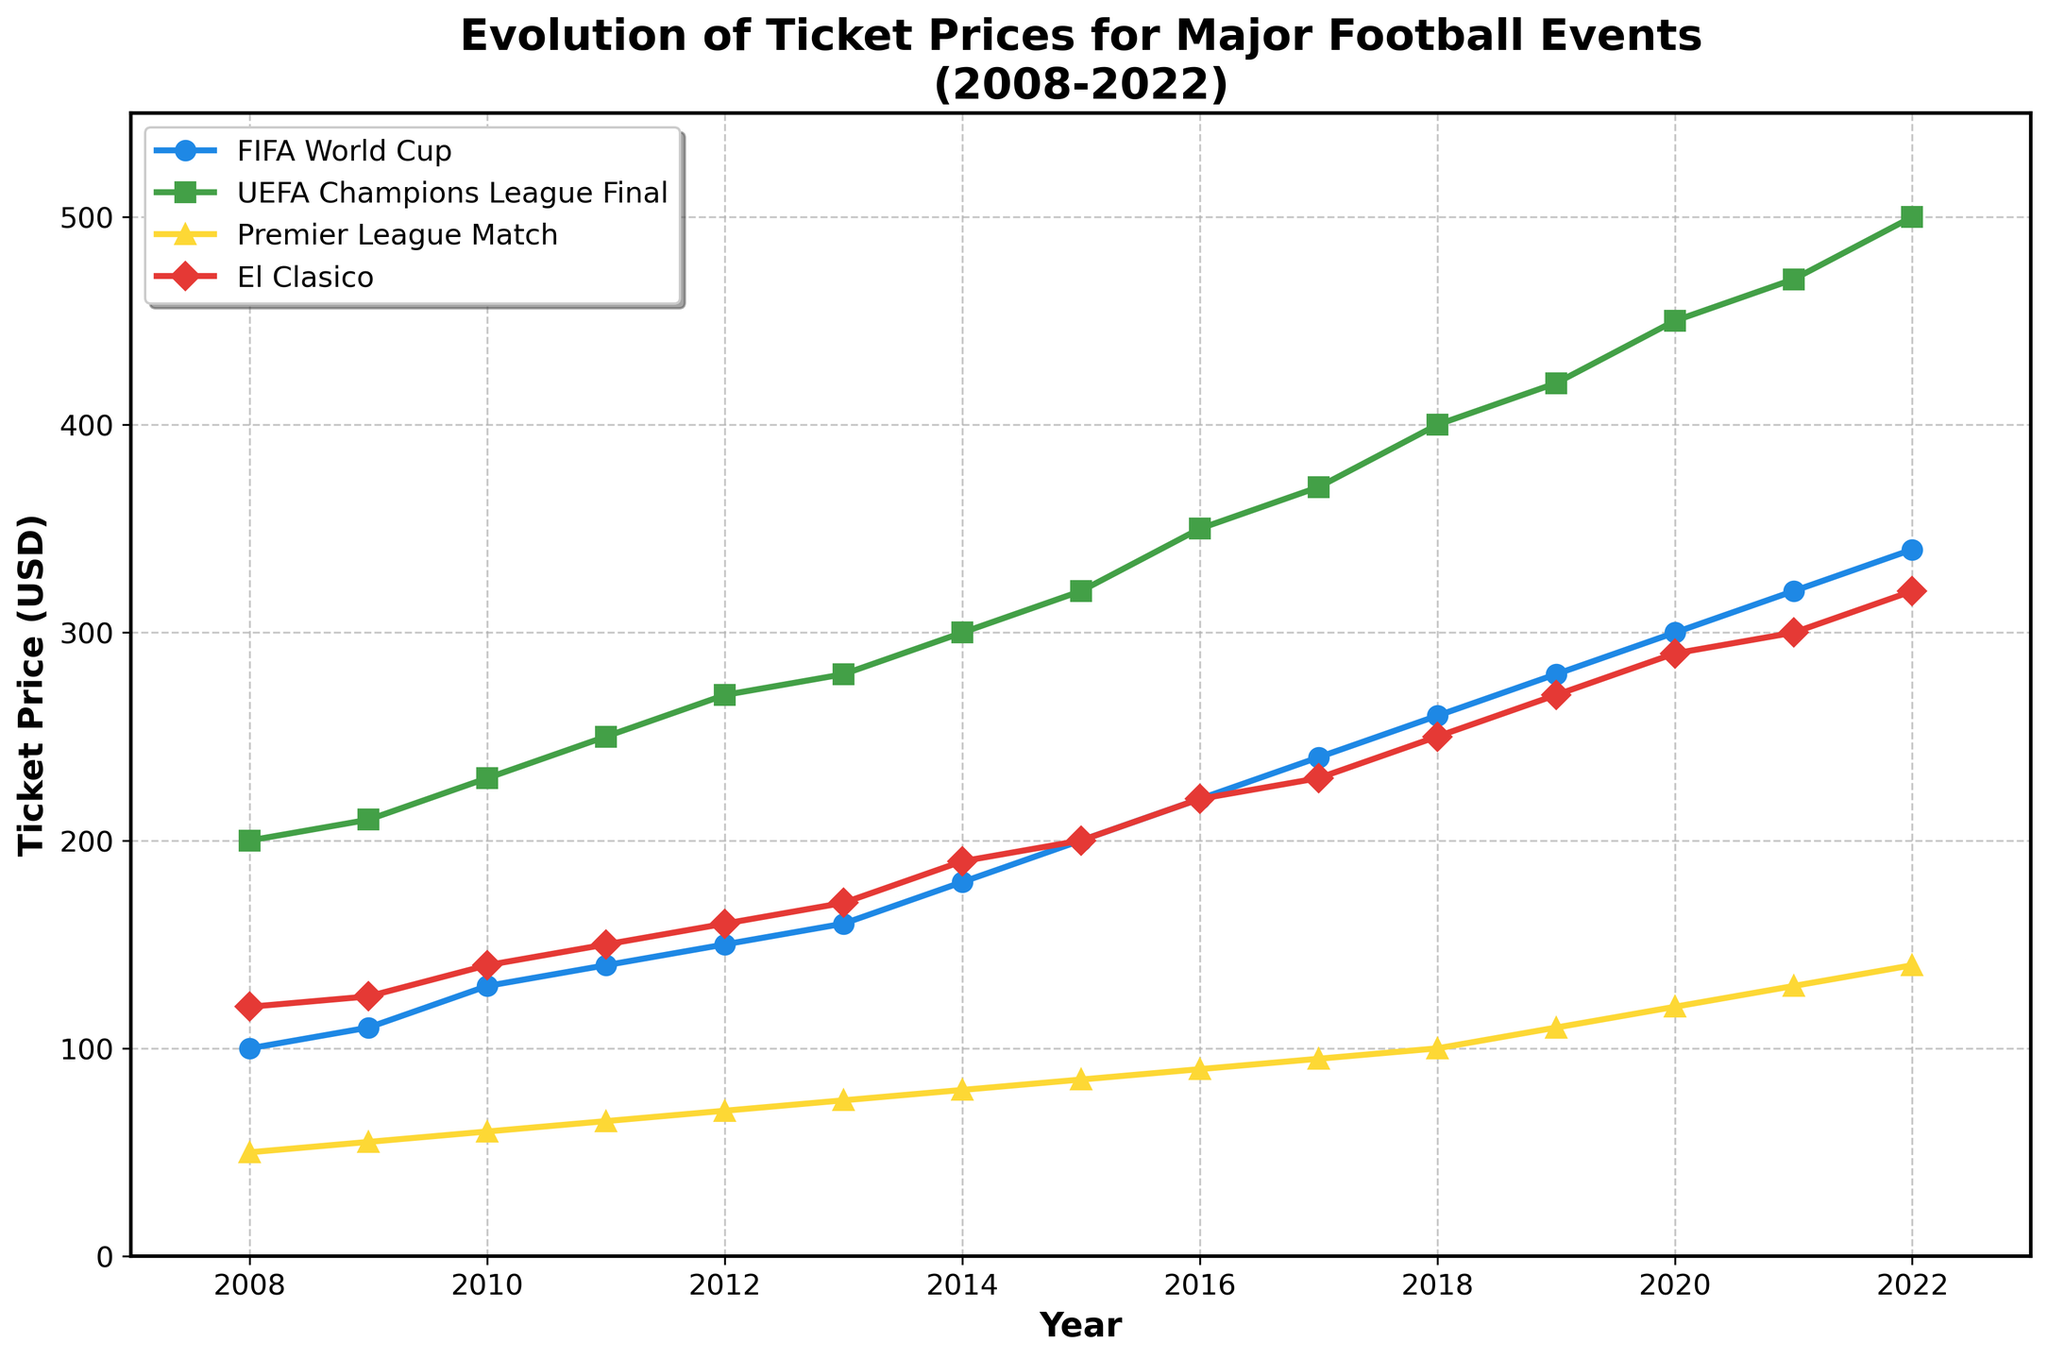Which event had the highest ticket price in 2022? Looking at the end of the plot for the year 2022, the "UEFA Champions League Final" had the highest ticket price at 500 USD.
Answer: UEFA Champions League Final What is the trend in ticket prices for Premier League Matches from 2008 to 2022? Observing the plot, there is a steady upward trend in the ticket prices for Premier League Matches from 50 USD in 2008 to 140 USD in 2022.
Answer: Increasing trend How much did the ticket price for El Clasico increase from 2008 to 2022? Comparing the ticket prices for El Clasico in 2008 and 2022, the price increased from 120 USD to 320 USD. The increase is 320 - 120 = 200 USD.
Answer: 200 USD Which event saw the largest increase in ticket price between 2008 and 2022? Calculating the ticket price increase for each event from 2008 to 2022:
- FIFA World Cup: 340 - 100 = 240 USD
- UEFA Champions League Final: 500 - 200 = 300 USD
- Premier League Match: 140 - 50 = 90 USD
- El Clasico: 320 - 120 = 200 USD
The UEFA Champions League Final saw the largest increase.
Answer: UEFA Champions League Final What's the average ticket price for FIFA World Cup in the years 2015-2020? Summing the FIFA World Cup ticket prices from 2015 to 2020: 200 + 220 + 240 + 260 + 280 + 300 = 1500 USD. There are 6 years, so the average is 1500 / 6 = 250 USD.
Answer: 250 USD Between 2010 and 2015, which event had the smallest increase in ticket price? Calculating the increase in ticket prices from 2010 to 2015:
- FIFA World Cup: 200 - 130 = 70 USD
- UEFA Champions League Final: 320 - 230 = 90 USD
- Premier League Match: 85 - 60 = 25 USD
- El Clasico: 200 - 140 = 60 USD
The Premier League Match had the smallest increase.
Answer: Premier League Match In what year did the FIFA World Cup ticket price first reach or exceed 200 USD? Looking at the plot, the FIFA World Cup ticket price first reached 200 USD in the year 2015.
Answer: 2015 Between 2018 and 2022, which event experienced the steepest rise in ticket price? Calculating the increase in ticket prices from 2018 to 2022:
- FIFA World Cup: 340 - 260 = 80 USD
- UEFA Champions League Final: 500 - 400 = 100 USD
- Premier League Match: 140 - 100 = 40 USD
- El Clasico: 320 - 250 = 70 USD
The UEFA Champions League Final experienced the steepest rise.
Answer: UEFA Champions League Final From 2008 to 2022, which event's ticket price growth rate appears most consistent on the plot? By visually inspecting the plot, the Premier League Match ticket prices exhibit a stable and consistent growth over the years.
Answer: Premier League Match 